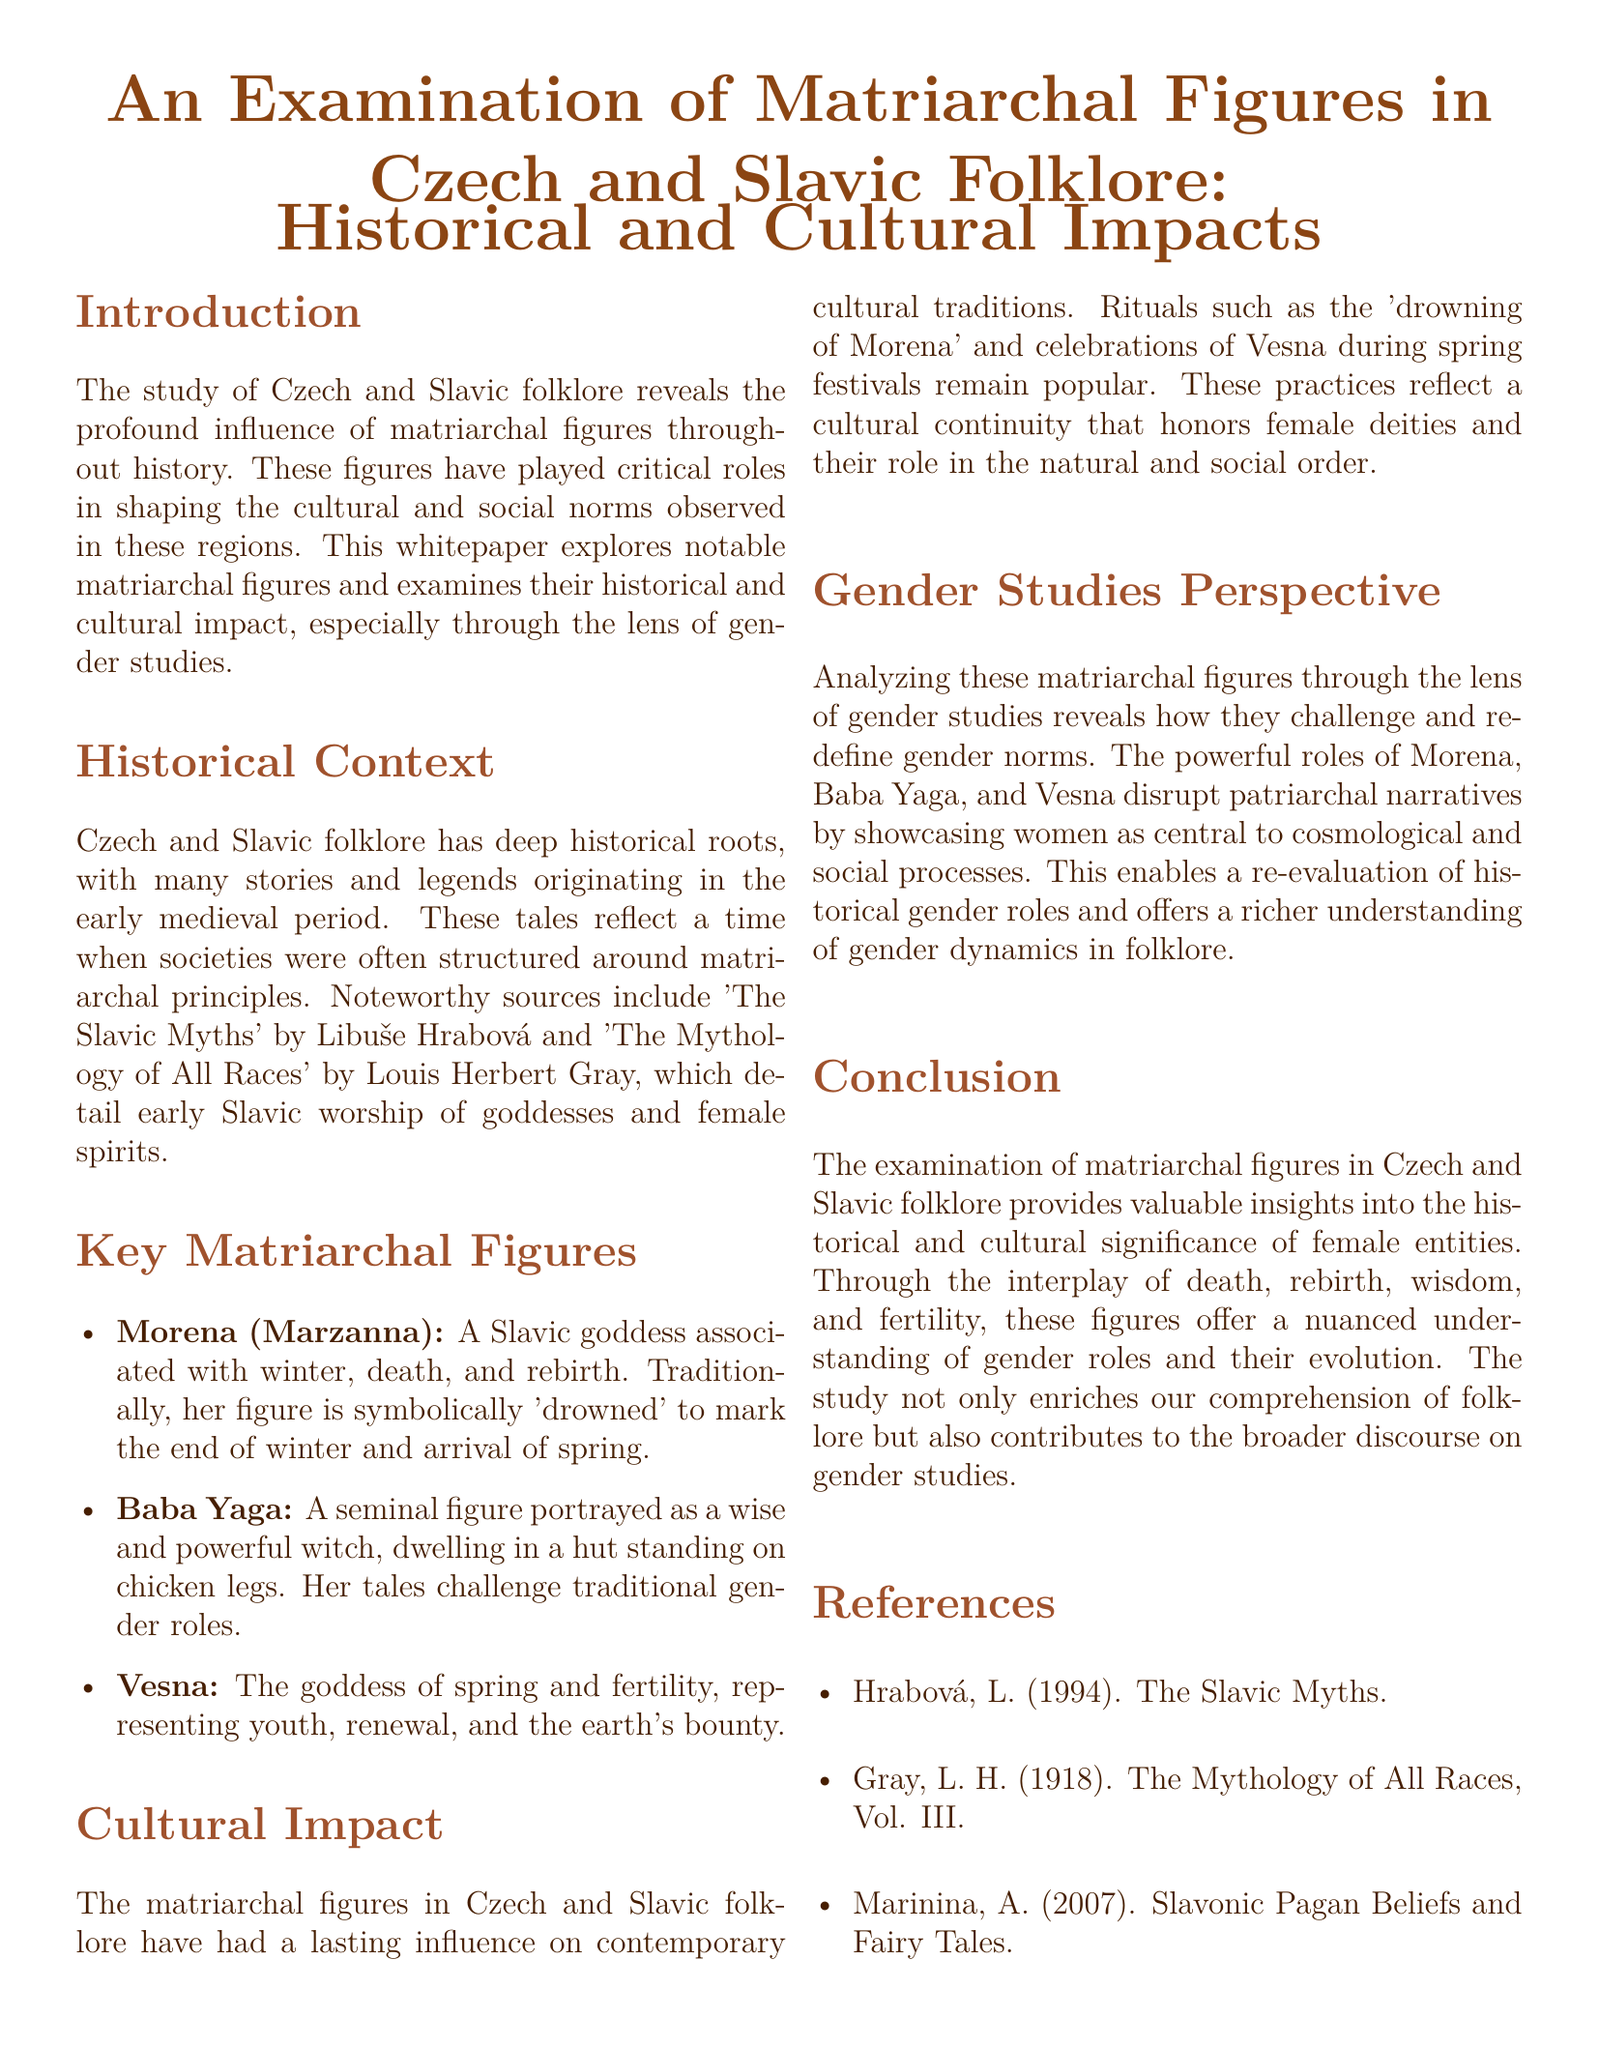What is the primary focus of this whitepaper? The primary focus is to explore notable matriarchal figures and their historical and cultural impact in Czech and Slavic folklore.
Answer: Matriarchal figures in Czech and Slavic folklore What does Morena symbolize? Morena is a Slavic goddess associated with winter, death, and rebirth, marking seasonal transitions.
Answer: Winter, death, and rebirth Who is portrayed as a wise and powerful witch? Baba Yaga is depicted as a wise and powerful witch in folklore.
Answer: Baba Yaga What significant influence do matriarchal figures have on contemporary cultural traditions? Matriarchal figures influence rituals and celebrations that honor female deities, reflecting cultural continuity.
Answer: Cultural continuity Which goddess represents spring and fertility? Vesna is the goddess representing spring and fertility in the folklore.
Answer: Vesna What year was "The Mythology of All Races" published? The publication year of "The Mythology of All Races" is 1918.
Answer: 1918 How do these matriarchal figures challenge traditional narratives? They challenge traditional narratives by showcasing women as central to cosmological and social processes.
Answer: By showcasing women’s central roles What type of analysis is provided in this whitepaper? The analysis is provided through the lens of gender studies, examining matriarchal figures.
Answer: Gender studies perspective What is the title of the first referenced work? The first referenced work is "The Slavic Myths."
Answer: The Slavic Myths 